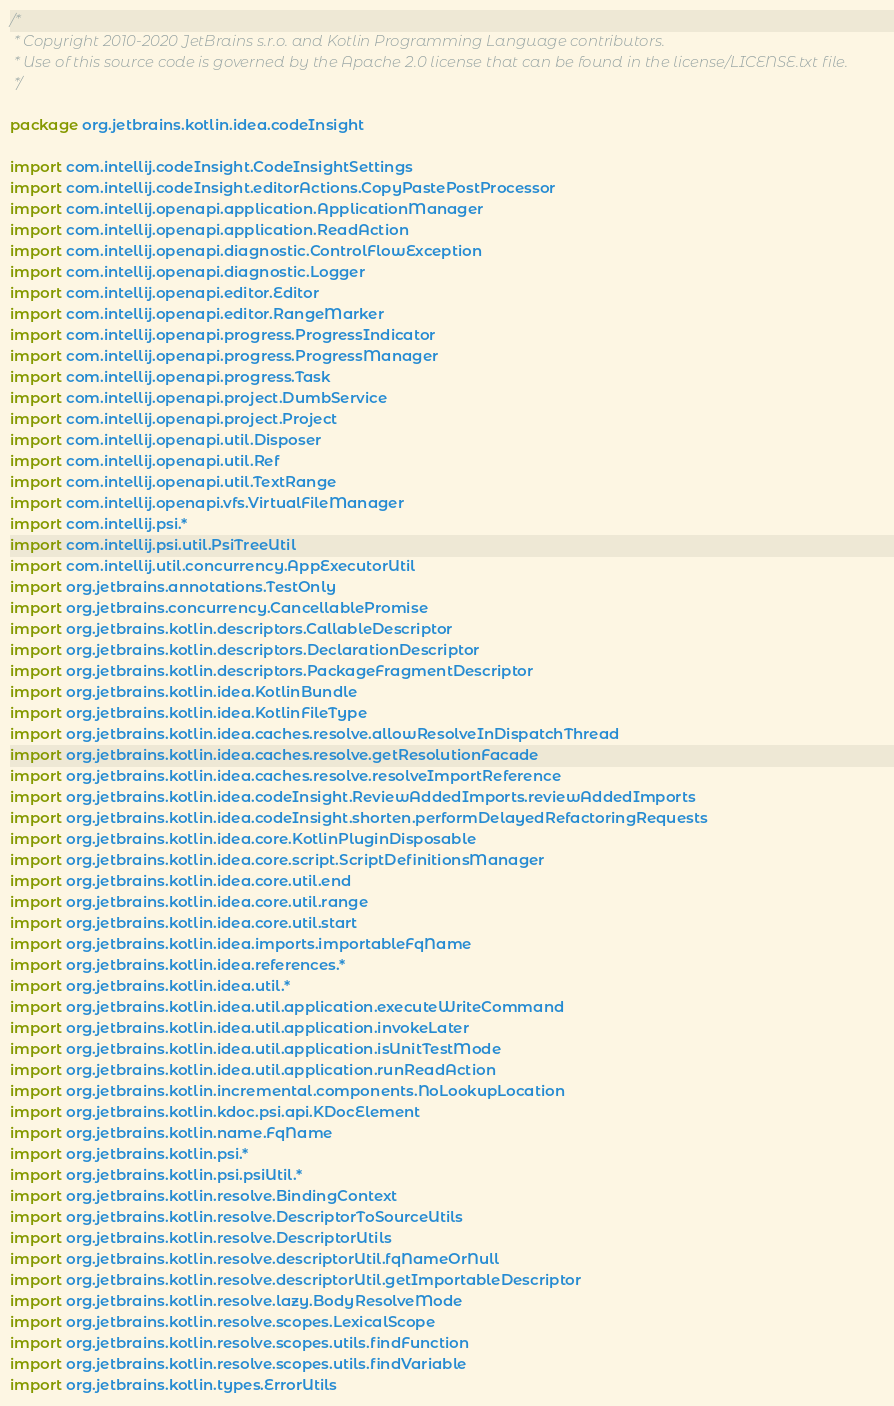<code> <loc_0><loc_0><loc_500><loc_500><_Kotlin_>/*
 * Copyright 2010-2020 JetBrains s.r.o. and Kotlin Programming Language contributors.
 * Use of this source code is governed by the Apache 2.0 license that can be found in the license/LICENSE.txt file.
 */

package org.jetbrains.kotlin.idea.codeInsight

import com.intellij.codeInsight.CodeInsightSettings
import com.intellij.codeInsight.editorActions.CopyPastePostProcessor
import com.intellij.openapi.application.ApplicationManager
import com.intellij.openapi.application.ReadAction
import com.intellij.openapi.diagnostic.ControlFlowException
import com.intellij.openapi.diagnostic.Logger
import com.intellij.openapi.editor.Editor
import com.intellij.openapi.editor.RangeMarker
import com.intellij.openapi.progress.ProgressIndicator
import com.intellij.openapi.progress.ProgressManager
import com.intellij.openapi.progress.Task
import com.intellij.openapi.project.DumbService
import com.intellij.openapi.project.Project
import com.intellij.openapi.util.Disposer
import com.intellij.openapi.util.Ref
import com.intellij.openapi.util.TextRange
import com.intellij.openapi.vfs.VirtualFileManager
import com.intellij.psi.*
import com.intellij.psi.util.PsiTreeUtil
import com.intellij.util.concurrency.AppExecutorUtil
import org.jetbrains.annotations.TestOnly
import org.jetbrains.concurrency.CancellablePromise
import org.jetbrains.kotlin.descriptors.CallableDescriptor
import org.jetbrains.kotlin.descriptors.DeclarationDescriptor
import org.jetbrains.kotlin.descriptors.PackageFragmentDescriptor
import org.jetbrains.kotlin.idea.KotlinBundle
import org.jetbrains.kotlin.idea.KotlinFileType
import org.jetbrains.kotlin.idea.caches.resolve.allowResolveInDispatchThread
import org.jetbrains.kotlin.idea.caches.resolve.getResolutionFacade
import org.jetbrains.kotlin.idea.caches.resolve.resolveImportReference
import org.jetbrains.kotlin.idea.codeInsight.ReviewAddedImports.reviewAddedImports
import org.jetbrains.kotlin.idea.codeInsight.shorten.performDelayedRefactoringRequests
import org.jetbrains.kotlin.idea.core.KotlinPluginDisposable
import org.jetbrains.kotlin.idea.core.script.ScriptDefinitionsManager
import org.jetbrains.kotlin.idea.core.util.end
import org.jetbrains.kotlin.idea.core.util.range
import org.jetbrains.kotlin.idea.core.util.start
import org.jetbrains.kotlin.idea.imports.importableFqName
import org.jetbrains.kotlin.idea.references.*
import org.jetbrains.kotlin.idea.util.*
import org.jetbrains.kotlin.idea.util.application.executeWriteCommand
import org.jetbrains.kotlin.idea.util.application.invokeLater
import org.jetbrains.kotlin.idea.util.application.isUnitTestMode
import org.jetbrains.kotlin.idea.util.application.runReadAction
import org.jetbrains.kotlin.incremental.components.NoLookupLocation
import org.jetbrains.kotlin.kdoc.psi.api.KDocElement
import org.jetbrains.kotlin.name.FqName
import org.jetbrains.kotlin.psi.*
import org.jetbrains.kotlin.psi.psiUtil.*
import org.jetbrains.kotlin.resolve.BindingContext
import org.jetbrains.kotlin.resolve.DescriptorToSourceUtils
import org.jetbrains.kotlin.resolve.DescriptorUtils
import org.jetbrains.kotlin.resolve.descriptorUtil.fqNameOrNull
import org.jetbrains.kotlin.resolve.descriptorUtil.getImportableDescriptor
import org.jetbrains.kotlin.resolve.lazy.BodyResolveMode
import org.jetbrains.kotlin.resolve.scopes.LexicalScope
import org.jetbrains.kotlin.resolve.scopes.utils.findFunction
import org.jetbrains.kotlin.resolve.scopes.utils.findVariable
import org.jetbrains.kotlin.types.ErrorUtils</code> 